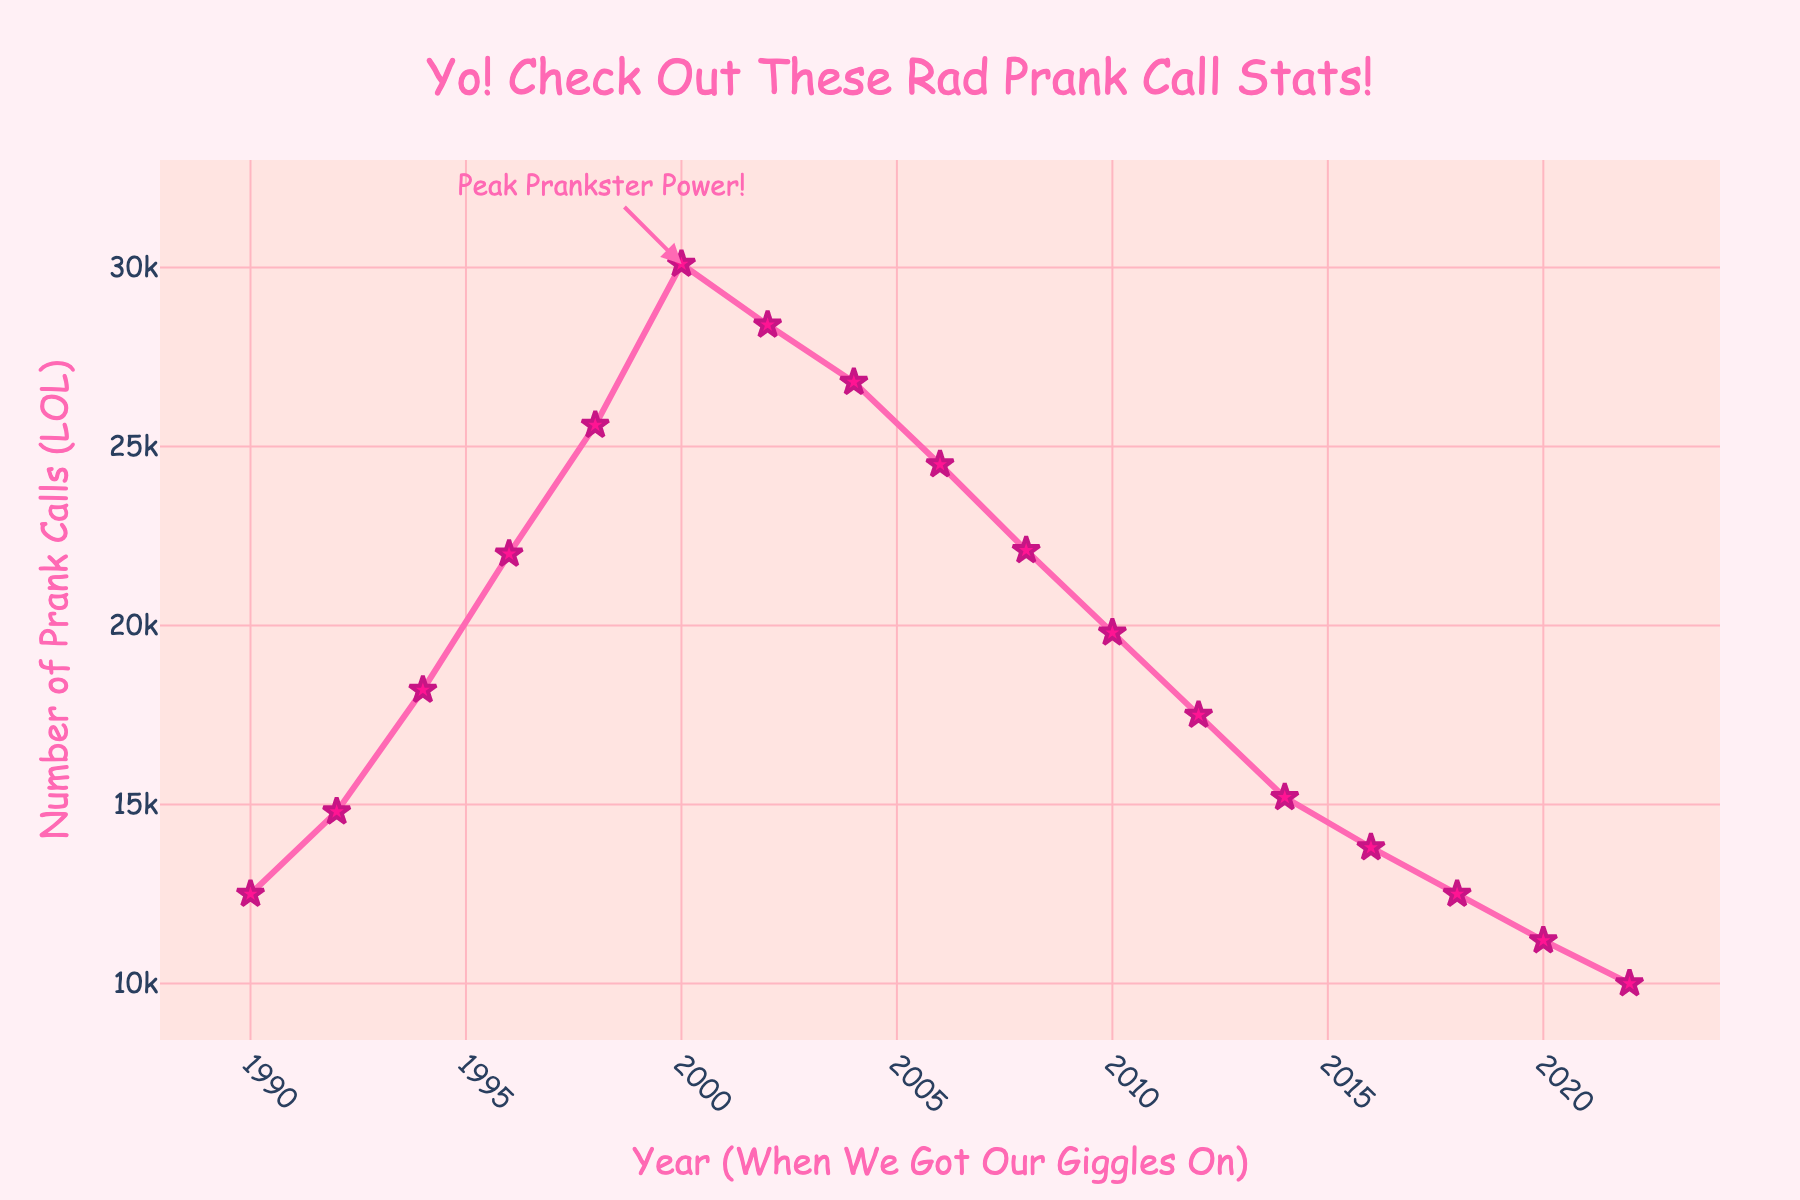Which year had the highest number of prank calls? Look at the plot and identify the year at the peak. The annotation "Peak Prankster Power!" indicates the peak.
Answer: 2000 Is the number of prank calls in 1996 greater than or less than in 2002? Check the graph by locating 1996 and 2002, then compare the heights of the markers for those years.
Answer: Greater What is the approximate decline in prank calls from the peak in 2000 to 2010? Find the values at 2000 and 2010 from the graph. Subtract the value in 2010 from the value in 2000.
Answer: 10300 Over which years did the prank calls drop consecutively? Look for a continuous downward trend in the line from one year to the next. From 2002 to 2022, you can see the values consistently decrease.
Answer: 2002-2022 Compare the number of prank calls in 1990 and 2022. Which year had fewer? Look at the plot and find the markers for 1990 and 2022. Compare the heights to determine which is lower.
Answer: 2022 Between which consecutive years did prank calls rise the most? Identify the biggest vertical jump between two consecutive years on the graph. Observe the jump between 1998 and 2000.
Answer: 1998-2000 Is the overall trend of prank calls increasing or decreasing over the years? Observe the general direction of the line from 1990 to 2022. Despite a peak in 2000, the overall direction is downward.
Answer: Decreasing Approximately how much did the prank calls decrease from 2006 to 2020? Find the values at 2006 and 2020 from the graph. Subtract the value in 2020 from the value in 2006.
Answer: 13300 